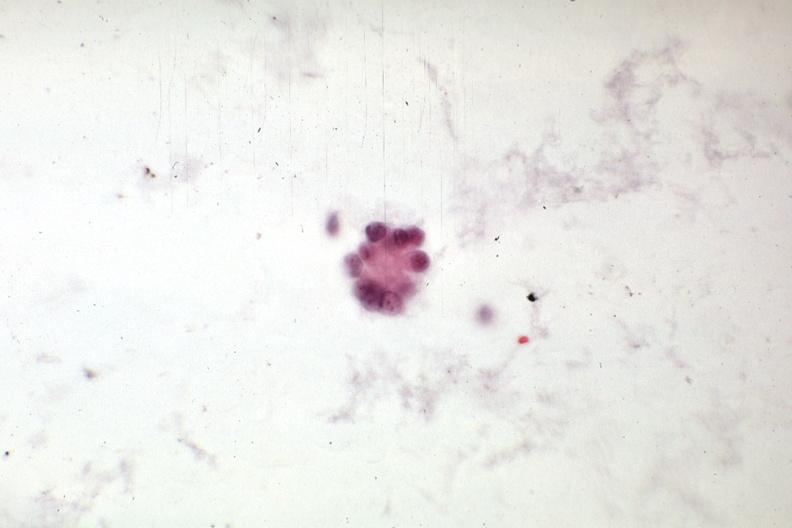what is present?
Answer the question using a single word or phrase. Abdomen 